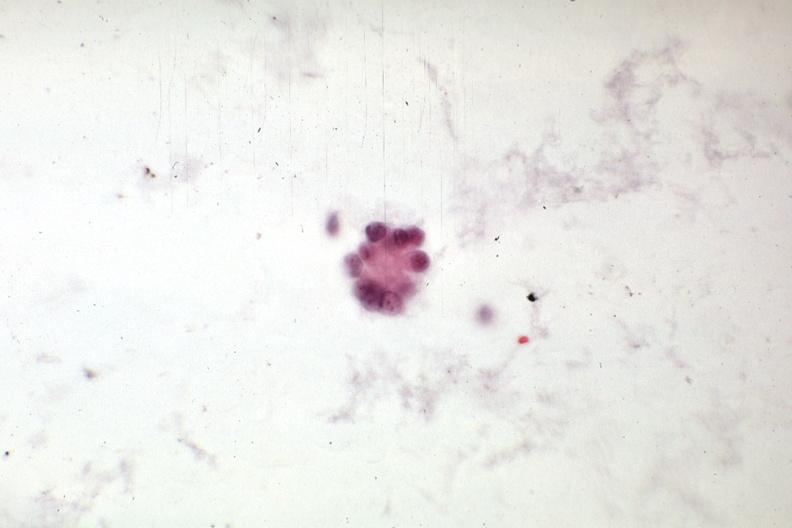what is present?
Answer the question using a single word or phrase. Abdomen 